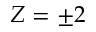Convert formula to latex. <formula><loc_0><loc_0><loc_500><loc_500>Z = \pm 2</formula> 